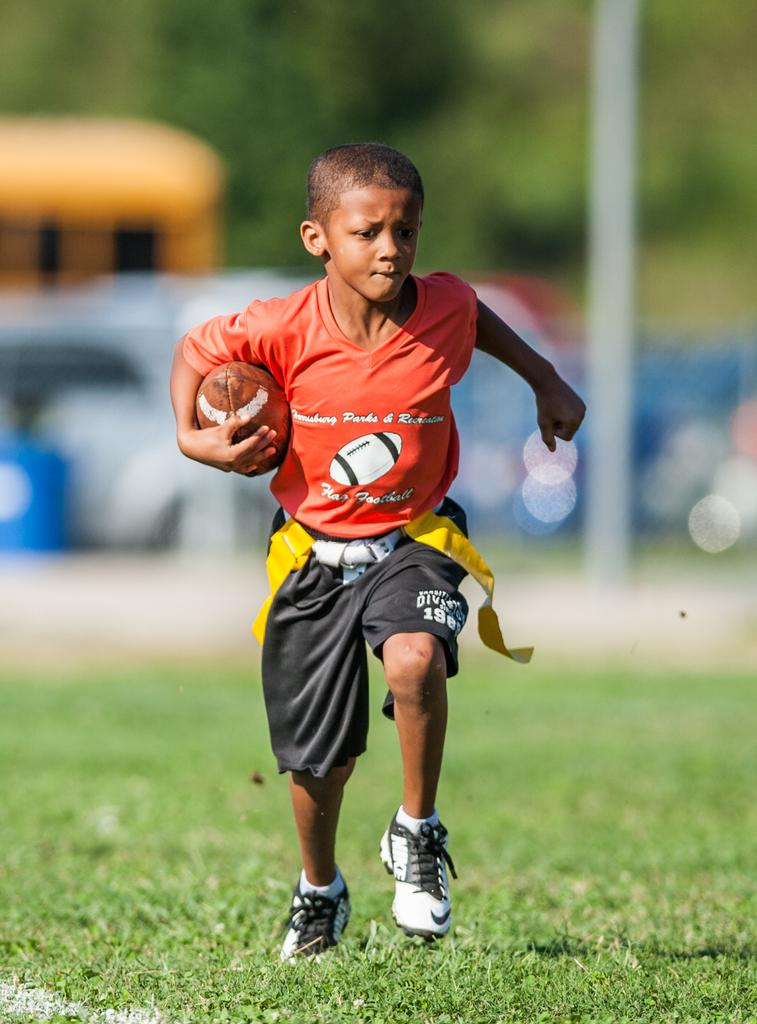Who is the main subject in the image? There is a boy in the image. What is the boy doing in the image? The boy is running on a field in the image. What is the boy holding in the image? The boy is holding a rugby ball in the image. What color is the boy's T-shirt in the image? The boy is wearing an orange T-shirt in the image. What color are the boy's shorts in the image? The boy is wearing black shorts in the image. What color are the boy's shoes in the image? The boy is wearing white shoes in the image. Can you tell me how many yaks are present in the image? There are no yaks present in the image; it features a boy running on a field with a rugby ball. What type of memory is being used by the boy in the image? The image does not depict any specific memory being used by the boy; it simply shows him running with a rugby ball. 